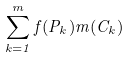<formula> <loc_0><loc_0><loc_500><loc_500>\sum _ { k = 1 } ^ { m } f ( P _ { k } ) m ( C _ { k } )</formula> 